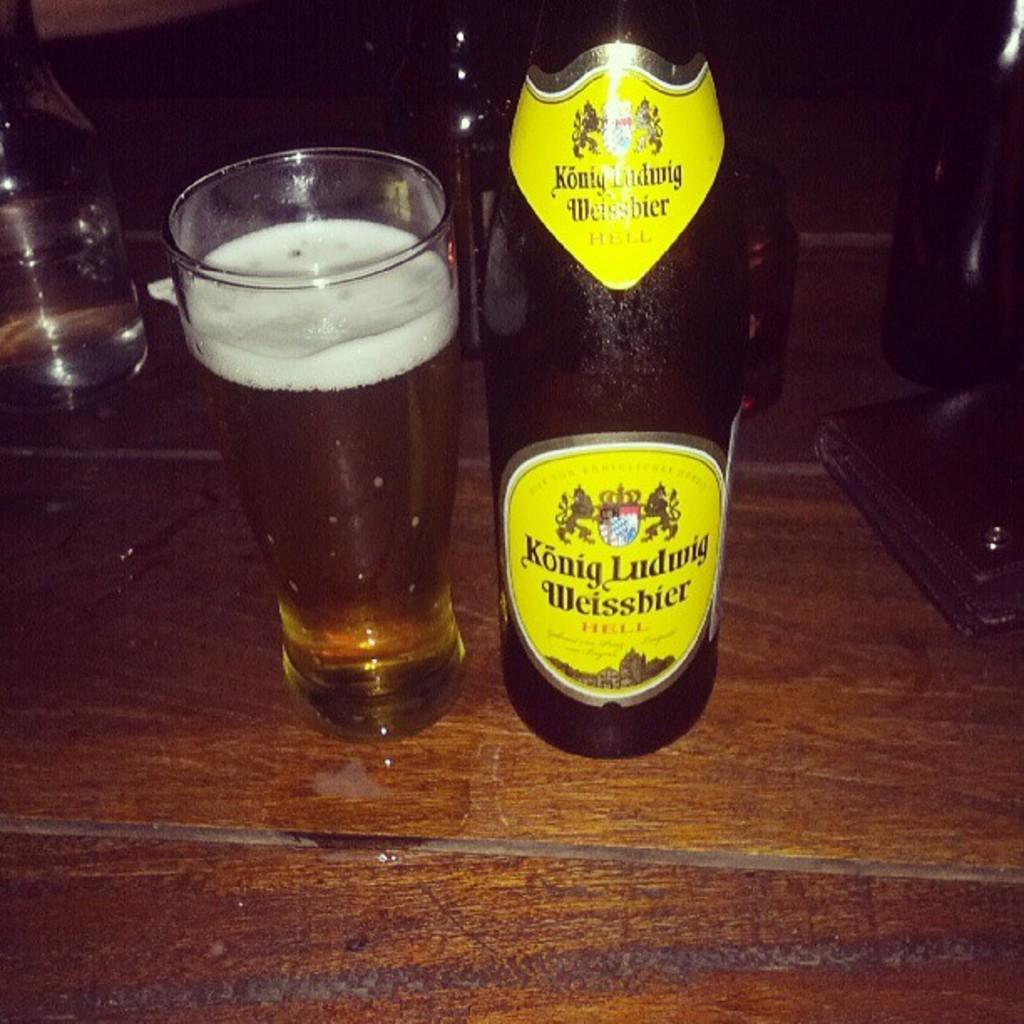<image>
Relay a brief, clear account of the picture shown. A large bottle of Konig Ludwig Weissbier is on a table with a full glass. 